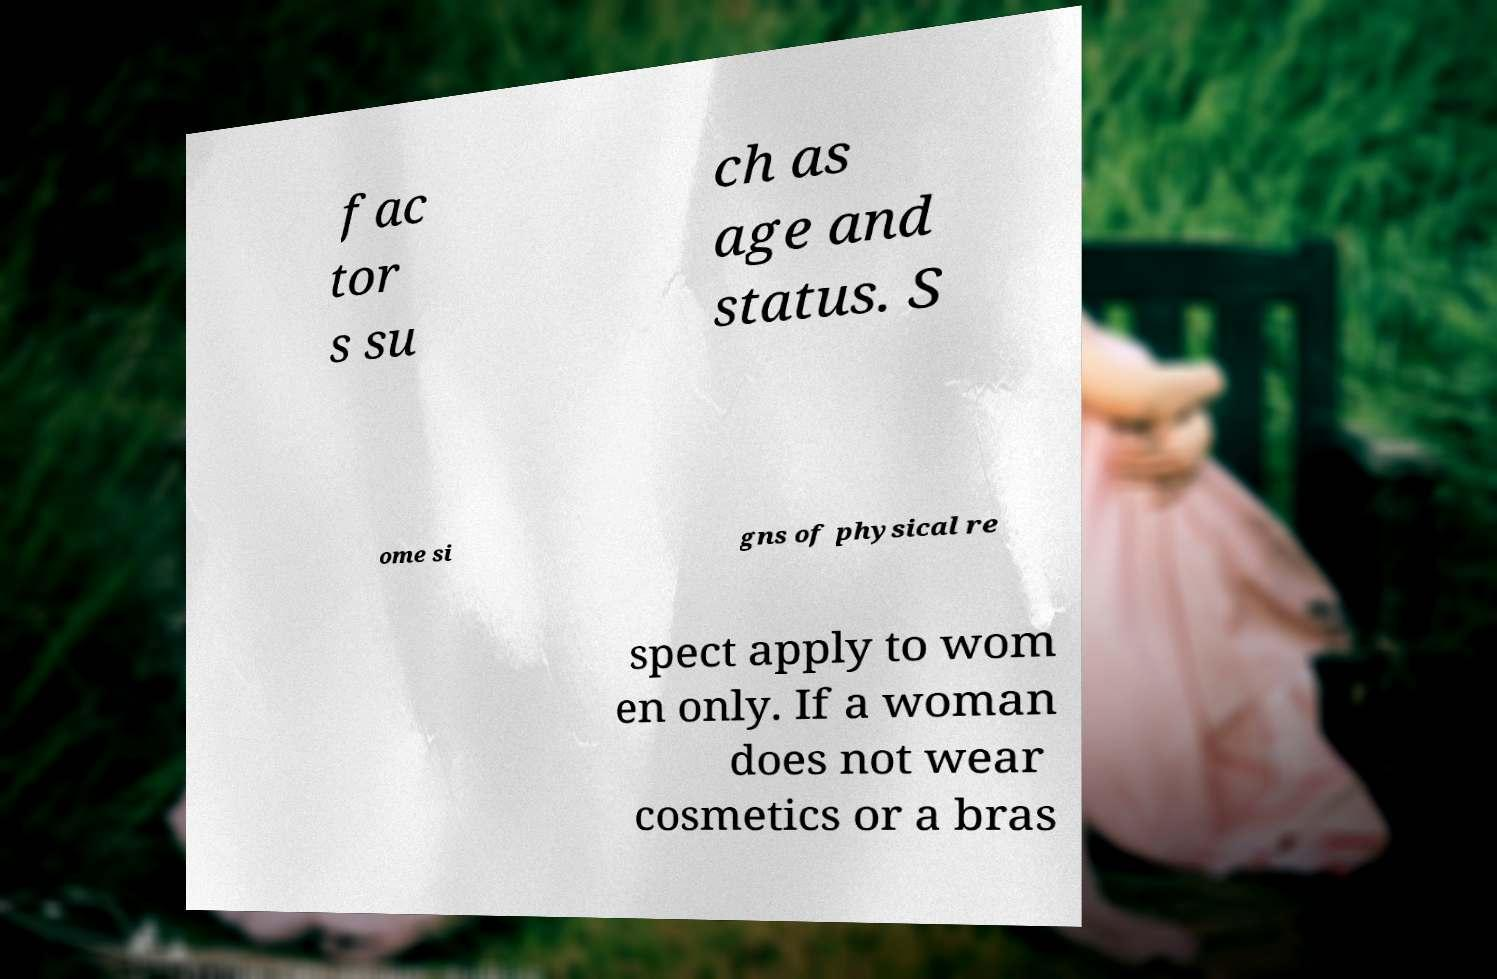Please read and relay the text visible in this image. What does it say? fac tor s su ch as age and status. S ome si gns of physical re spect apply to wom en only. If a woman does not wear cosmetics or a bras 